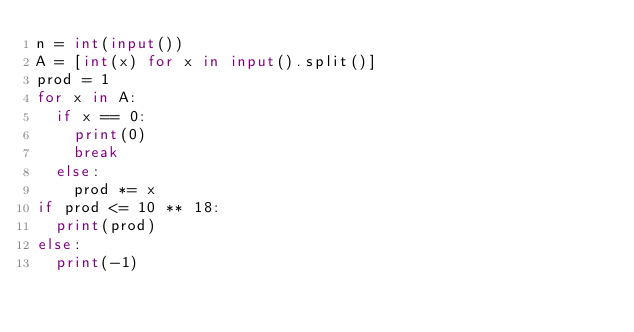<code> <loc_0><loc_0><loc_500><loc_500><_Python_>n = int(input())
A = [int(x) for x in input().split()]
prod = 1
for x in A:
  if x == 0:
    print(0)
    break
  else:
  	prod *= x
if prod <= 10 ** 18:
  print(prod)
else:
  print(-1)</code> 